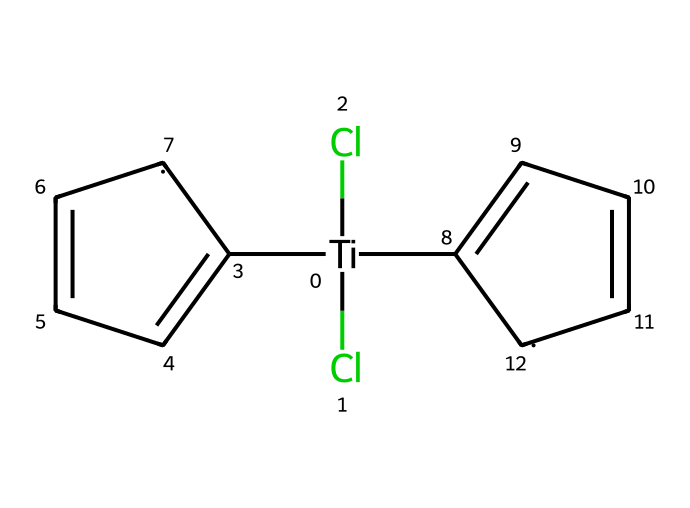What is the oxidation state of titanium in titanocene dichloride? Titanium (Ti) is bonded to two chlorine (Cl) atoms and two cyclopentadienyl groups (C5H5). The oxidation state can be calculated as follows: since each Cl is in the -1 oxidation state, and each cyclopentadienyl is neutral, the oxidation state of Ti must be +4 (the sum of -2 from Cl and 0 from C5H5 will equal 0).
Answer: +4 How many chlorine atoms are present in titanocene dichloride? The SMILES representation shows two chlorine (Cl) atoms connected to titanium (Ti). There are no other Cl atoms mentioned in the structure.
Answer: 2 Which type of chemical bond connects titanium to chlorine? In titanocene dichloride, titanium is connected to chlorine atoms through ionic bonds, as Ti typically forms ionic bonds when bonding with halogens such as Cl.
Answer: ionic What is the coordination number of titanium in this compound? The coordination number refers to the total number of ligand bonds to a central metal atom. In titanocene dichloride, titanium has two chlorine ligands and two cyclopentadienyl groups, leading to a coordination number of 4.
Answer: 4 How many cyclopentadienyl groups are in titanocene dichloride? The structure shows two cyclopentadienyl groups (C5H5) attached to titanium, which are represented as rings in the SMILES notation.
Answer: 2 What type of organometallic compound is titanocene dichloride classified as? Titanocene dichloride is classified as a metallocene, which is a subtype of organometallic compounds characterized by a transition metal sandwiched between two cyclopentadienyl anions.
Answer: metallocene What bonding geometry is expected around the titanium center in this compound? Considering the four coordination sites occupied by two chloride ions and two cyclopentadienyl rings, the bonding geometry around titanium is generally described as tetrahedral due to the arrangement and repulsion of the ligands.
Answer: tetrahedral 